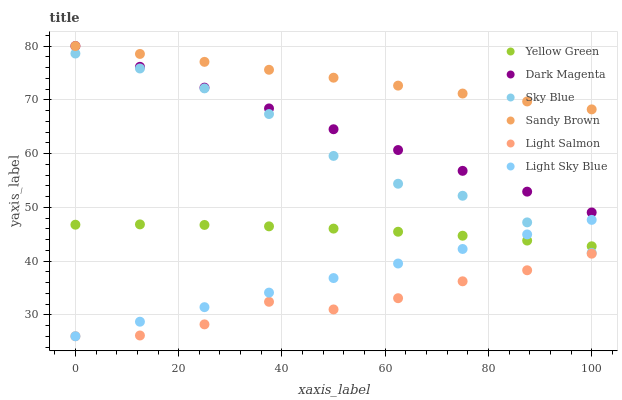Does Light Salmon have the minimum area under the curve?
Answer yes or no. Yes. Does Sandy Brown have the maximum area under the curve?
Answer yes or no. Yes. Does Yellow Green have the minimum area under the curve?
Answer yes or no. No. Does Yellow Green have the maximum area under the curve?
Answer yes or no. No. Is Light Sky Blue the smoothest?
Answer yes or no. Yes. Is Light Salmon the roughest?
Answer yes or no. Yes. Is Yellow Green the smoothest?
Answer yes or no. No. Is Yellow Green the roughest?
Answer yes or no. No. Does Light Salmon have the lowest value?
Answer yes or no. Yes. Does Yellow Green have the lowest value?
Answer yes or no. No. Does Dark Magenta have the highest value?
Answer yes or no. Yes. Does Yellow Green have the highest value?
Answer yes or no. No. Is Sky Blue less than Dark Magenta?
Answer yes or no. Yes. Is Dark Magenta greater than Yellow Green?
Answer yes or no. Yes. Does Light Sky Blue intersect Yellow Green?
Answer yes or no. Yes. Is Light Sky Blue less than Yellow Green?
Answer yes or no. No. Is Light Sky Blue greater than Yellow Green?
Answer yes or no. No. Does Sky Blue intersect Dark Magenta?
Answer yes or no. No. 